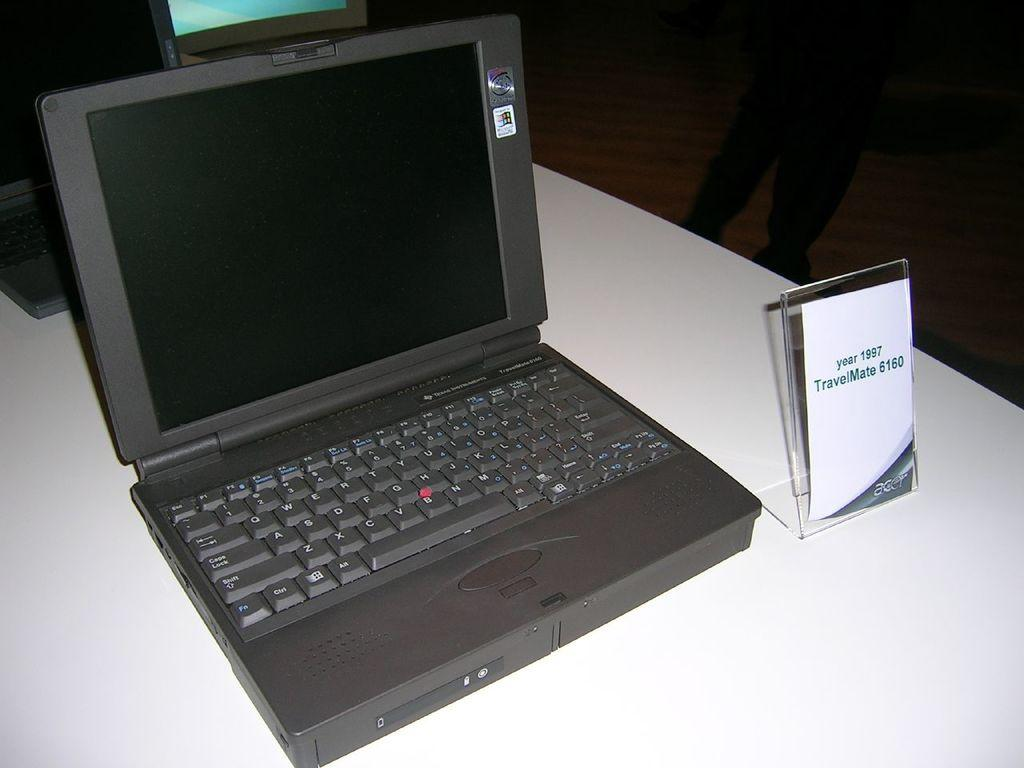<image>
Write a terse but informative summary of the picture. a travelmate 6160 from 1997 on display on a white table 